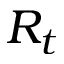Convert formula to latex. <formula><loc_0><loc_0><loc_500><loc_500>R _ { t }</formula> 